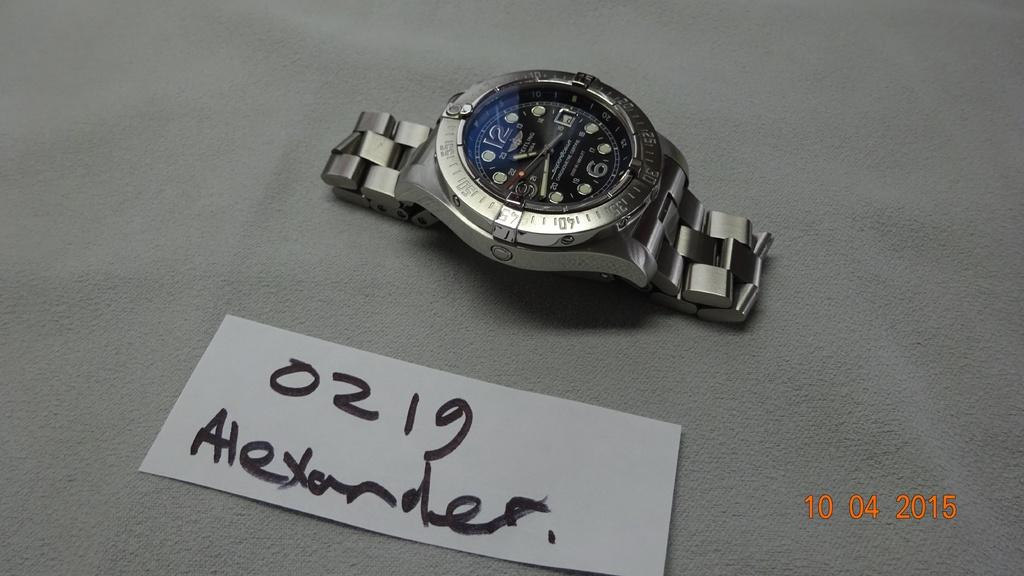<image>
Render a clear and concise summary of the photo. A watch with a blue face sits near a card that says 0129. 